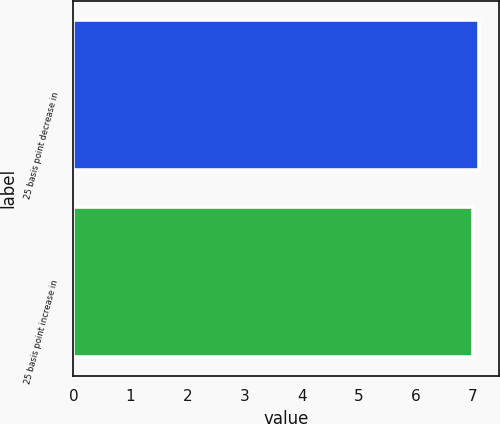Convert chart to OTSL. <chart><loc_0><loc_0><loc_500><loc_500><bar_chart><fcel>25 basis point decrease in<fcel>25 basis point increase in<nl><fcel>7.1<fcel>7<nl></chart> 